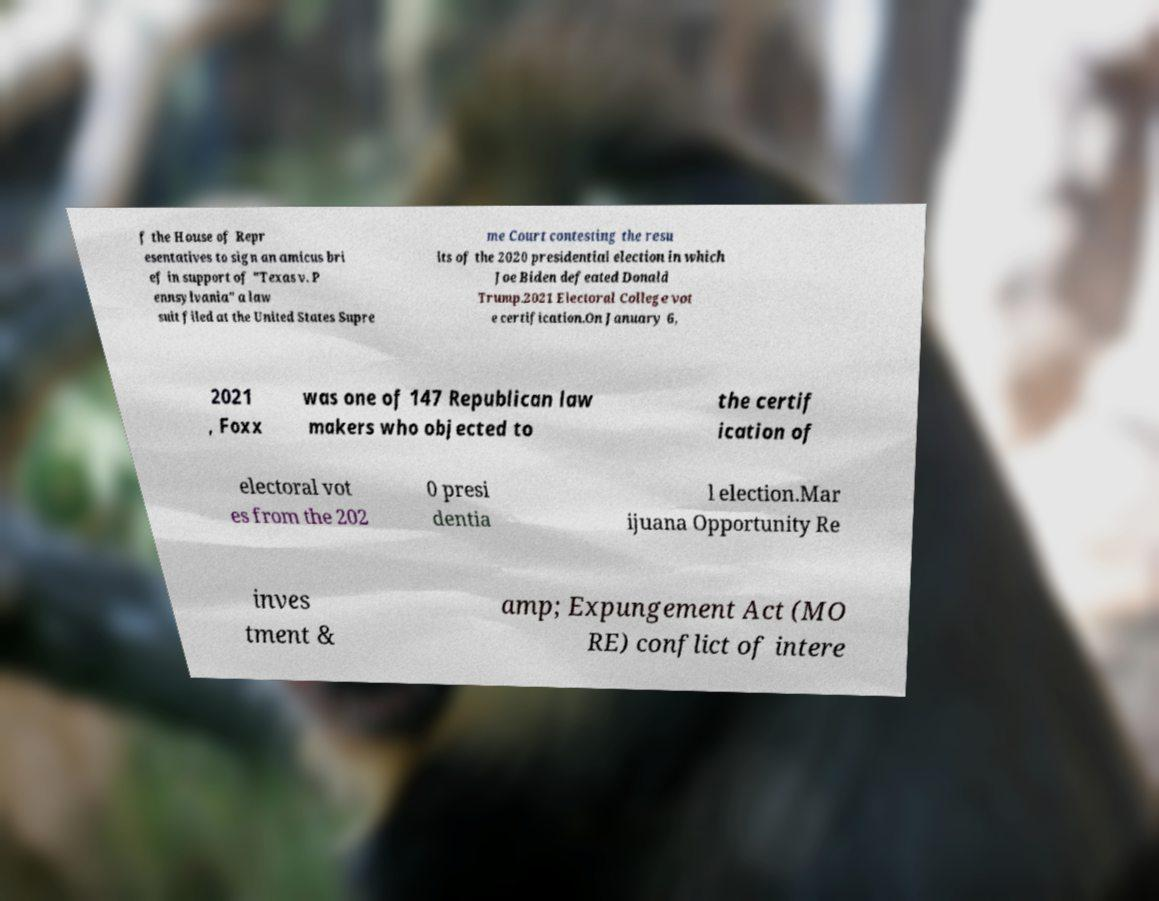I need the written content from this picture converted into text. Can you do that? f the House of Repr esentatives to sign an amicus bri ef in support of "Texas v. P ennsylvania" a law suit filed at the United States Supre me Court contesting the resu lts of the 2020 presidential election in which Joe Biden defeated Donald Trump.2021 Electoral College vot e certification.On January 6, 2021 , Foxx was one of 147 Republican law makers who objected to the certif ication of electoral vot es from the 202 0 presi dentia l election.Mar ijuana Opportunity Re inves tment & amp; Expungement Act (MO RE) conflict of intere 